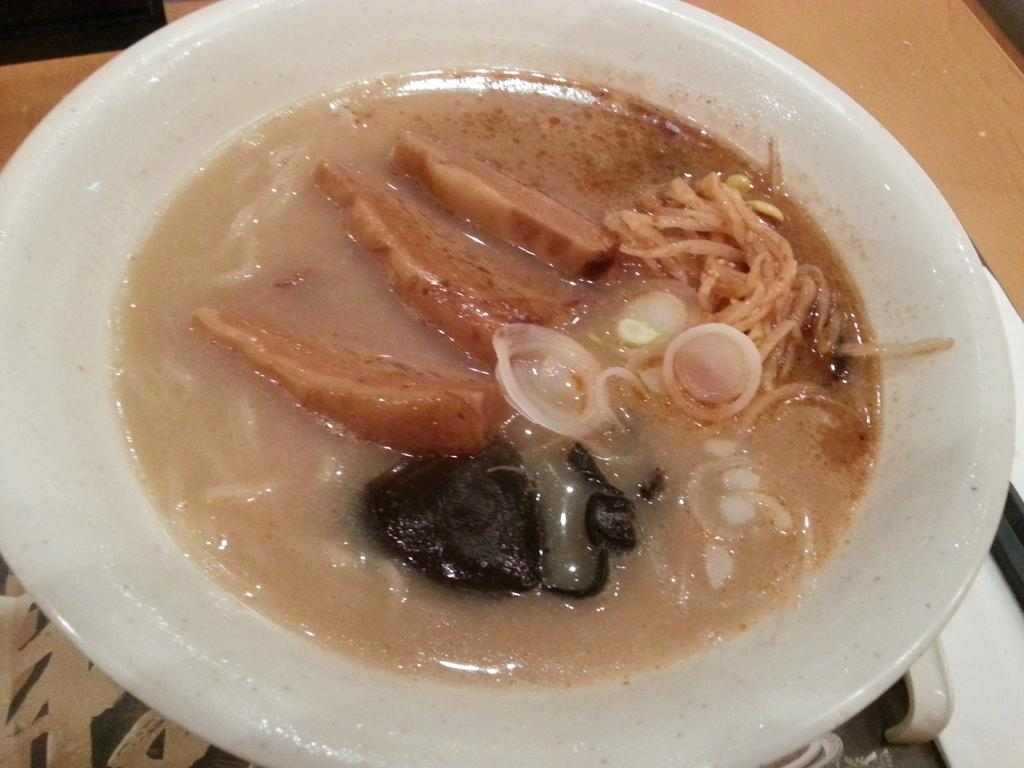What is in the bowl that is visible in the image? There is food in a bowl in the image. Where is the bowl located in the image? The bowl is placed on a table. What type of appliance can be seen hanging from a hook near the seashore in the image? There is no appliance or hook near the seashore in the image, as the facts only mention a bowl of food on a table. 